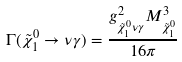<formula> <loc_0><loc_0><loc_500><loc_500>\Gamma ( \tilde { \chi } ^ { 0 } _ { 1 } \rightarrow \nu \gamma ) = \frac { g ^ { 2 } _ { { \tilde { \chi } ^ { 0 } _ { 1 } } \nu \gamma } M ^ { 3 } _ { \tilde { \chi } ^ { 0 } _ { 1 } } } { 1 6 \pi }</formula> 